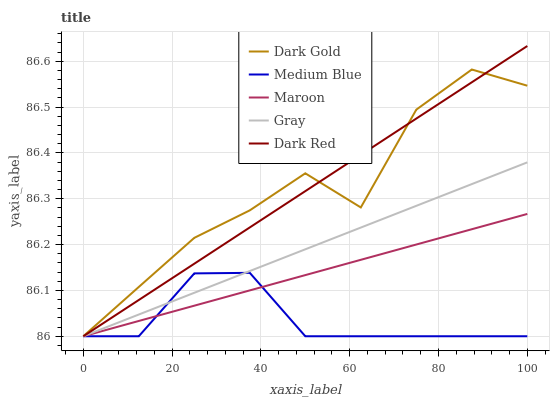Does Medium Blue have the minimum area under the curve?
Answer yes or no. Yes. Does Dark Gold have the maximum area under the curve?
Answer yes or no. Yes. Does Dark Red have the minimum area under the curve?
Answer yes or no. No. Does Dark Red have the maximum area under the curve?
Answer yes or no. No. Is Maroon the smoothest?
Answer yes or no. Yes. Is Dark Gold the roughest?
Answer yes or no. Yes. Is Dark Red the smoothest?
Answer yes or no. No. Is Dark Red the roughest?
Answer yes or no. No. Does Dark Red have the highest value?
Answer yes or no. Yes. Does Medium Blue have the highest value?
Answer yes or no. No. Does Dark Gold intersect Maroon?
Answer yes or no. Yes. Is Dark Gold less than Maroon?
Answer yes or no. No. Is Dark Gold greater than Maroon?
Answer yes or no. No. 